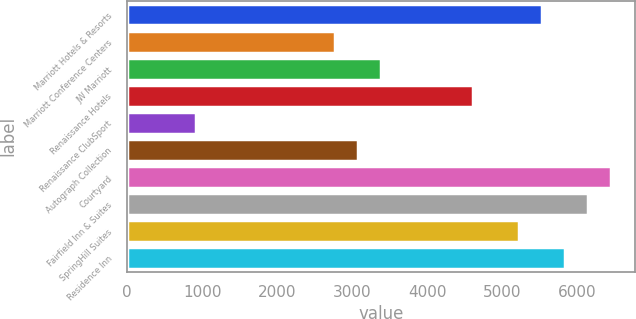Convert chart. <chart><loc_0><loc_0><loc_500><loc_500><bar_chart><fcel>Marriott Hotels & Resorts<fcel>Marriott Conference Centers<fcel>JW Marriott<fcel>Renaissance Hotels<fcel>Renaissance ClubSport<fcel>Autograph Collection<fcel>Courtyard<fcel>Fairfield Inn & Suites<fcel>SpringHill Suites<fcel>Residence Inn<nl><fcel>5532.68<fcel>2766.71<fcel>3381.37<fcel>4610.69<fcel>922.73<fcel>3074.04<fcel>6454.67<fcel>6147.34<fcel>5225.35<fcel>5840.01<nl></chart> 